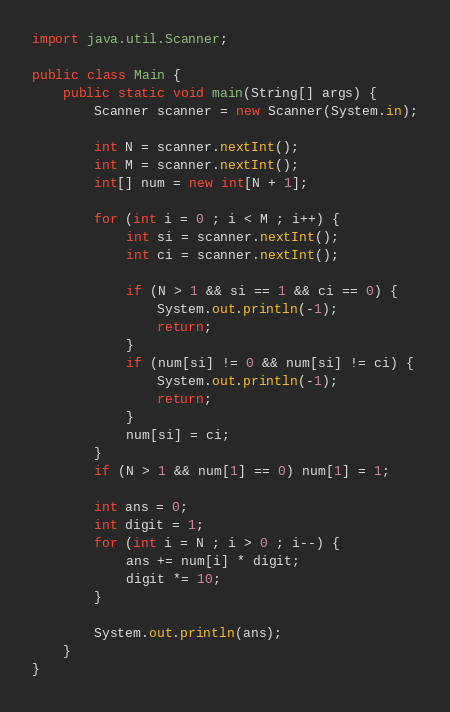<code> <loc_0><loc_0><loc_500><loc_500><_Java_>
import java.util.Scanner;

public class Main {
    public static void main(String[] args) {
        Scanner scanner = new Scanner(System.in);

        int N = scanner.nextInt();
        int M = scanner.nextInt();
        int[] num = new int[N + 1];

        for (int i = 0 ; i < M ; i++) {
            int si = scanner.nextInt();
            int ci = scanner.nextInt();

            if (N > 1 && si == 1 && ci == 0) {
                System.out.println(-1);
                return;
            }
            if (num[si] != 0 && num[si] != ci) {
                System.out.println(-1);
                return;
            }
            num[si] = ci;
        }
        if (N > 1 && num[1] == 0) num[1] = 1;

        int ans = 0;
        int digit = 1;
        for (int i = N ; i > 0 ; i--) {
            ans += num[i] * digit;
            digit *= 10;
        }

        System.out.println(ans);
    }
}
</code> 